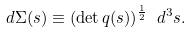Convert formula to latex. <formula><loc_0><loc_0><loc_500><loc_500>d \Sigma ( s ) \equiv ( \det q ( s ) ) ^ { \frac { 1 } { 2 } } \ d ^ { 3 } s .</formula> 